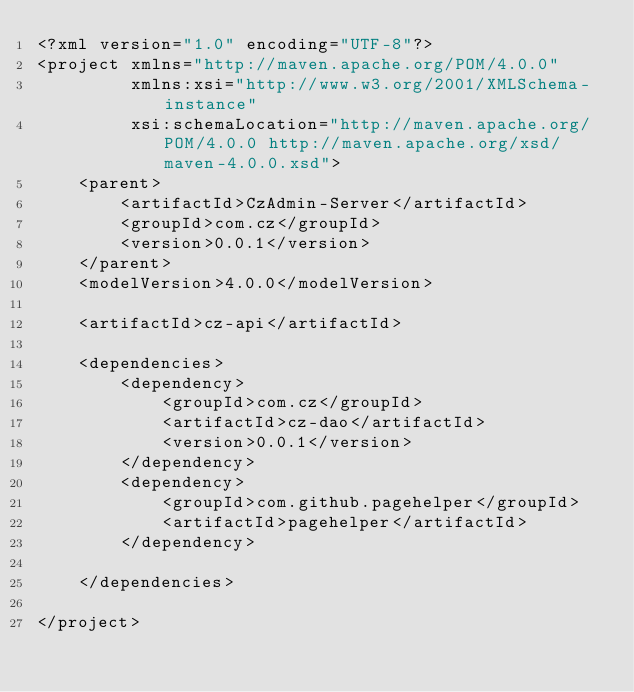<code> <loc_0><loc_0><loc_500><loc_500><_XML_><?xml version="1.0" encoding="UTF-8"?>
<project xmlns="http://maven.apache.org/POM/4.0.0"
         xmlns:xsi="http://www.w3.org/2001/XMLSchema-instance"
         xsi:schemaLocation="http://maven.apache.org/POM/4.0.0 http://maven.apache.org/xsd/maven-4.0.0.xsd">
    <parent>
        <artifactId>CzAdmin-Server</artifactId>
        <groupId>com.cz</groupId>
        <version>0.0.1</version>
    </parent>
    <modelVersion>4.0.0</modelVersion>

    <artifactId>cz-api</artifactId>

    <dependencies>
        <dependency>
            <groupId>com.cz</groupId>
            <artifactId>cz-dao</artifactId>
            <version>0.0.1</version>
        </dependency>
        <dependency>
            <groupId>com.github.pagehelper</groupId>
            <artifactId>pagehelper</artifactId>
        </dependency>

    </dependencies>

</project></code> 